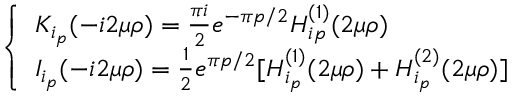Convert formula to latex. <formula><loc_0><loc_0><loc_500><loc_500>\left \{ \begin{array} { l l } { { K _ { i _ { p } } ( - i 2 \mu \rho ) = \frac { \pi i } { 2 } e ^ { - \pi p / 2 } H _ { i p } ^ { ( 1 ) } ( 2 \mu \rho ) } } \\ { { I _ { i _ { p } } ( - i 2 \mu \rho ) = \frac { 1 } { 2 } e ^ { \pi p / 2 } [ H _ { i _ { p } } ^ { ( 1 ) } ( 2 \mu \rho ) + H _ { i _ { p } } ^ { ( 2 ) } ( 2 \mu \rho ) ] } } \end{array}</formula> 